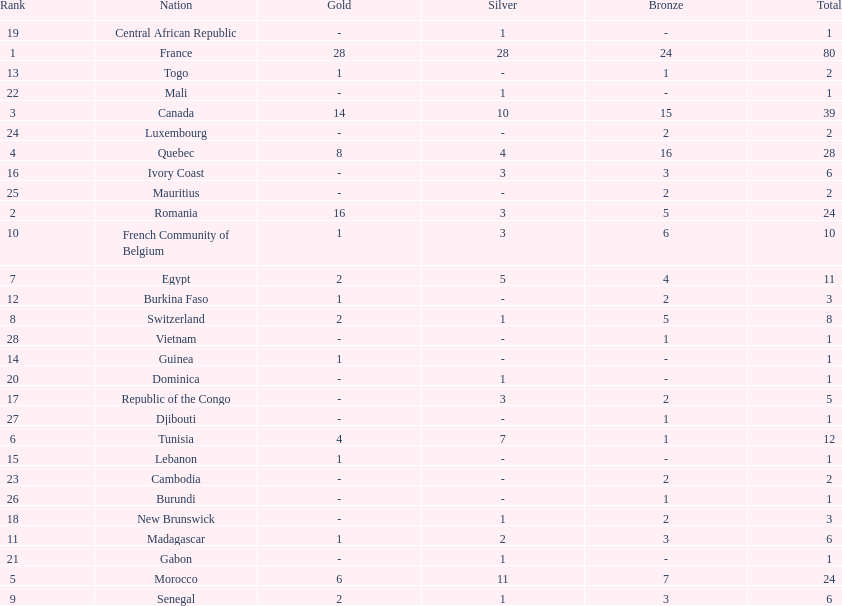What is the difference between france's and egypt's silver medals? 23. 